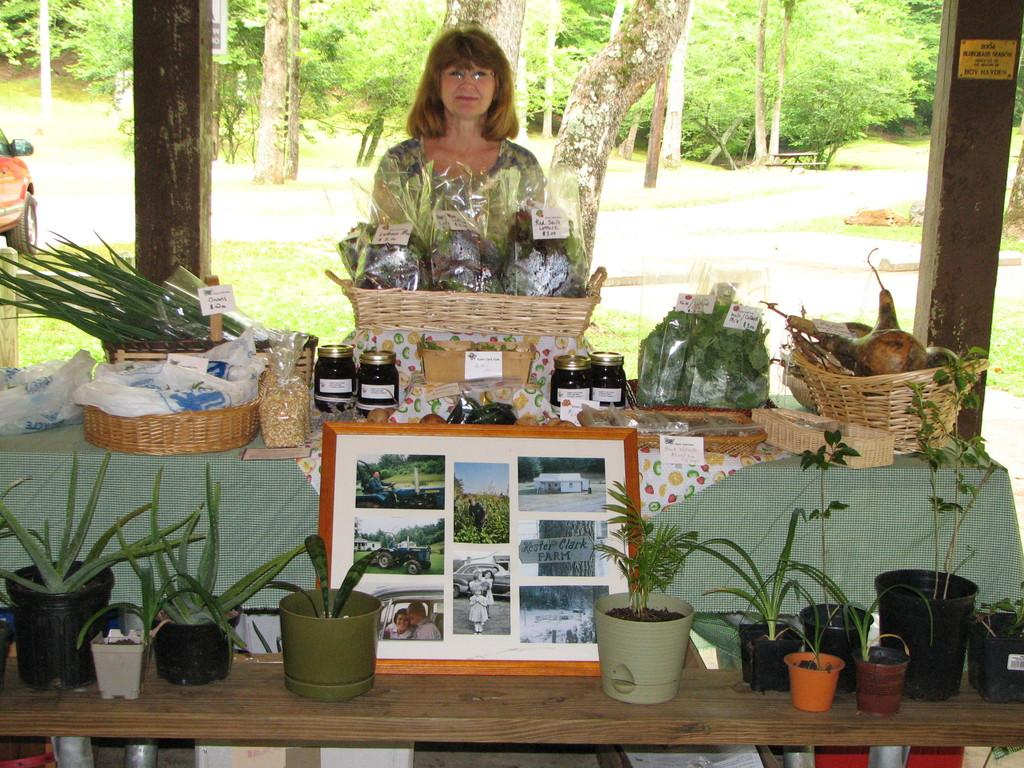What is the woman in the image doing? The woman is standing behind a table. What items can be seen on the table? There are vegetables, bottles, a photo frame, and pots on the table. What can be seen in the background of the image? There are trees and a car in the background of the image. What time does the clock show in the image? There is no clock present in the image. 